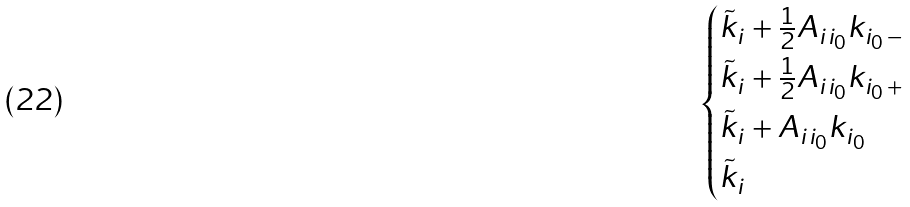Convert formula to latex. <formula><loc_0><loc_0><loc_500><loc_500>\begin{cases} \tilde { k } _ { i } + \frac { 1 } { 2 } A _ { i i _ { 0 } } k _ { i _ { 0 } \, - } \\ \tilde { k } _ { i } + \frac { 1 } { 2 } A _ { i i _ { 0 } } k _ { i _ { 0 } \, + } \\ \tilde { k } _ { i } + A _ { i i _ { 0 } } k _ { i _ { 0 } } \\ \tilde { k } _ { i } \end{cases}</formula> 